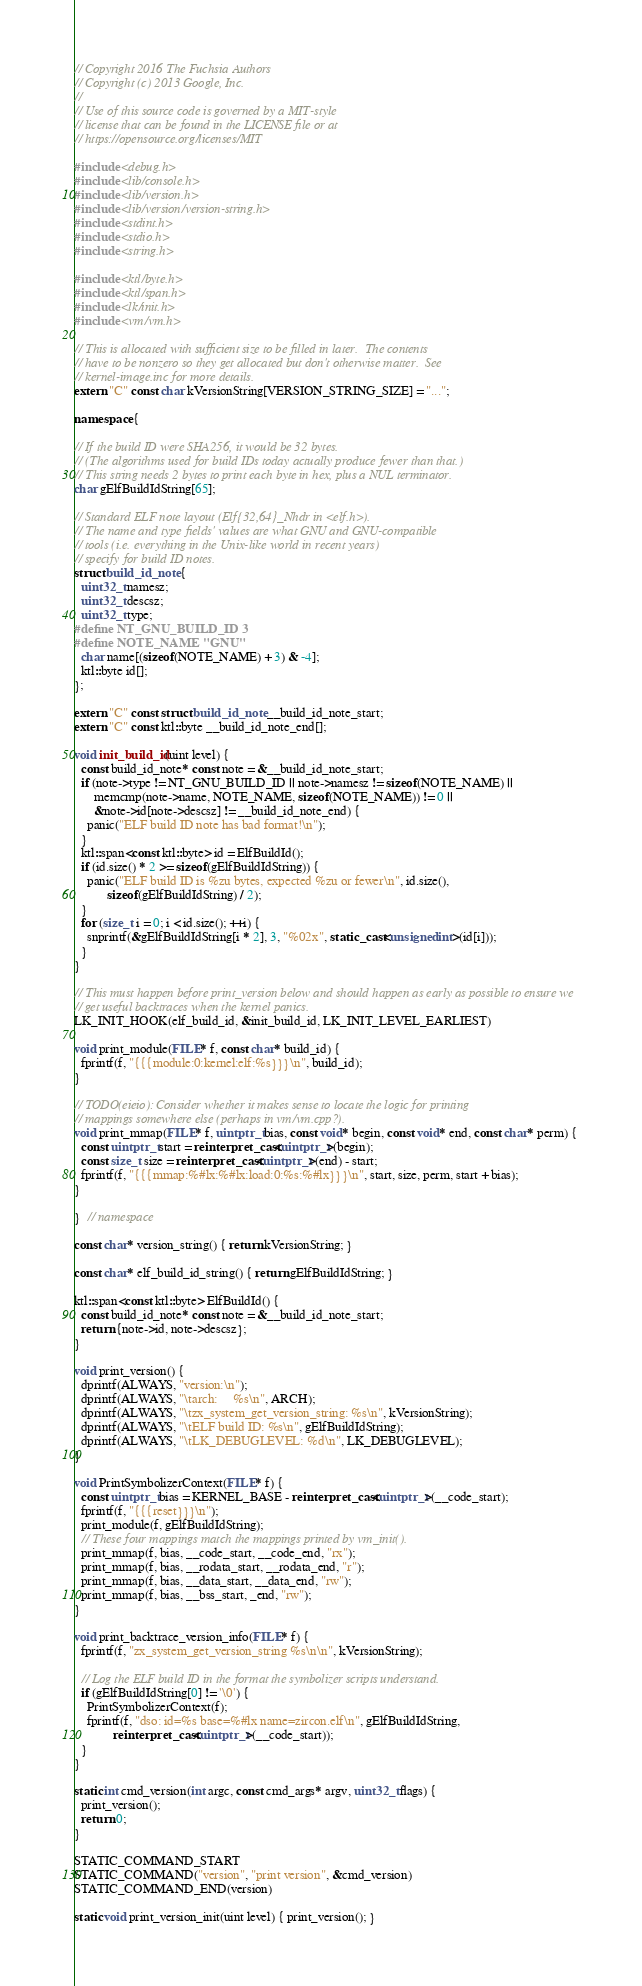Convert code to text. <code><loc_0><loc_0><loc_500><loc_500><_C++_>// Copyright 2016 The Fuchsia Authors
// Copyright (c) 2013 Google, Inc.
//
// Use of this source code is governed by a MIT-style
// license that can be found in the LICENSE file or at
// https://opensource.org/licenses/MIT

#include <debug.h>
#include <lib/console.h>
#include <lib/version.h>
#include <lib/version/version-string.h>
#include <stdint.h>
#include <stdio.h>
#include <string.h>

#include <ktl/byte.h>
#include <ktl/span.h>
#include <lk/init.h>
#include <vm/vm.h>

// This is allocated with sufficient size to be filled in later.  The contents
// have to be nonzero so they get allocated but don't otherwise matter.  See
// kernel-image.inc for more details.
extern "C" const char kVersionString[VERSION_STRING_SIZE] = "...";

namespace {

// If the build ID were SHA256, it would be 32 bytes.
// (The algorithms used for build IDs today actually produce fewer than that.)
// This string needs 2 bytes to print each byte in hex, plus a NUL terminator.
char gElfBuildIdString[65];

// Standard ELF note layout (Elf{32,64}_Nhdr in <elf.h>).
// The name and type fields' values are what GNU and GNU-compatible
// tools (i.e. everything in the Unix-like world in recent years)
// specify for build ID notes.
struct build_id_note {
  uint32_t namesz;
  uint32_t descsz;
  uint32_t type;
#define NT_GNU_BUILD_ID 3
#define NOTE_NAME "GNU"
  char name[(sizeof(NOTE_NAME) + 3) & -4];
  ktl::byte id[];
};

extern "C" const struct build_id_note __build_id_note_start;
extern "C" const ktl::byte __build_id_note_end[];

void init_build_id(uint level) {
  const build_id_note* const note = &__build_id_note_start;
  if (note->type != NT_GNU_BUILD_ID || note->namesz != sizeof(NOTE_NAME) ||
      memcmp(note->name, NOTE_NAME, sizeof(NOTE_NAME)) != 0 ||
      &note->id[note->descsz] != __build_id_note_end) {
    panic("ELF build ID note has bad format!\n");
  }
  ktl::span<const ktl::byte> id = ElfBuildId();
  if (id.size() * 2 >= sizeof(gElfBuildIdString)) {
    panic("ELF build ID is %zu bytes, expected %zu or fewer\n", id.size(),
          sizeof(gElfBuildIdString) / 2);
  }
  for (size_t i = 0; i < id.size(); ++i) {
    snprintf(&gElfBuildIdString[i * 2], 3, "%02x", static_cast<unsigned int>(id[i]));
  }
}

// This must happen before print_version below and should happen as early as possible to ensure we
// get useful backtraces when the kernel panics.
LK_INIT_HOOK(elf_build_id, &init_build_id, LK_INIT_LEVEL_EARLIEST)

void print_module(FILE* f, const char* build_id) {
  fprintf(f, "{{{module:0:kernel:elf:%s}}}\n", build_id);
}

// TODO(eieio): Consider whether it makes sense to locate the logic for printing
// mappings somewhere else (perhaps in vm/vm.cpp?).
void print_mmap(FILE* f, uintptr_t bias, const void* begin, const void* end, const char* perm) {
  const uintptr_t start = reinterpret_cast<uintptr_t>(begin);
  const size_t size = reinterpret_cast<uintptr_t>(end) - start;
  fprintf(f, "{{{mmap:%#lx:%#lx:load:0:%s:%#lx}}}\n", start, size, perm, start + bias);
}

}  // namespace

const char* version_string() { return kVersionString; }

const char* elf_build_id_string() { return gElfBuildIdString; }

ktl::span<const ktl::byte> ElfBuildId() {
  const build_id_note* const note = &__build_id_note_start;
  return {note->id, note->descsz};
}

void print_version() {
  dprintf(ALWAYS, "version:\n");
  dprintf(ALWAYS, "\tarch:     %s\n", ARCH);
  dprintf(ALWAYS, "\tzx_system_get_version_string: %s\n", kVersionString);
  dprintf(ALWAYS, "\tELF build ID: %s\n", gElfBuildIdString);
  dprintf(ALWAYS, "\tLK_DEBUGLEVEL: %d\n", LK_DEBUGLEVEL);
}

void PrintSymbolizerContext(FILE* f) {
  const uintptr_t bias = KERNEL_BASE - reinterpret_cast<uintptr_t>(__code_start);
  fprintf(f, "{{{reset}}}\n");
  print_module(f, gElfBuildIdString);
  // These four mappings match the mappings printed by vm_init().
  print_mmap(f, bias, __code_start, __code_end, "rx");
  print_mmap(f, bias, __rodata_start, __rodata_end, "r");
  print_mmap(f, bias, __data_start, __data_end, "rw");
  print_mmap(f, bias, __bss_start, _end, "rw");
}

void print_backtrace_version_info(FILE* f) {
  fprintf(f, "zx_system_get_version_string %s\n\n", kVersionString);

  // Log the ELF build ID in the format the symbolizer scripts understand.
  if (gElfBuildIdString[0] != '\0') {
    PrintSymbolizerContext(f);
    fprintf(f, "dso: id=%s base=%#lx name=zircon.elf\n", gElfBuildIdString,
            reinterpret_cast<uintptr_t>(__code_start));
  }
}

static int cmd_version(int argc, const cmd_args* argv, uint32_t flags) {
  print_version();
  return 0;
}

STATIC_COMMAND_START
STATIC_COMMAND("version", "print version", &cmd_version)
STATIC_COMMAND_END(version)

static void print_version_init(uint level) { print_version(); }
</code> 